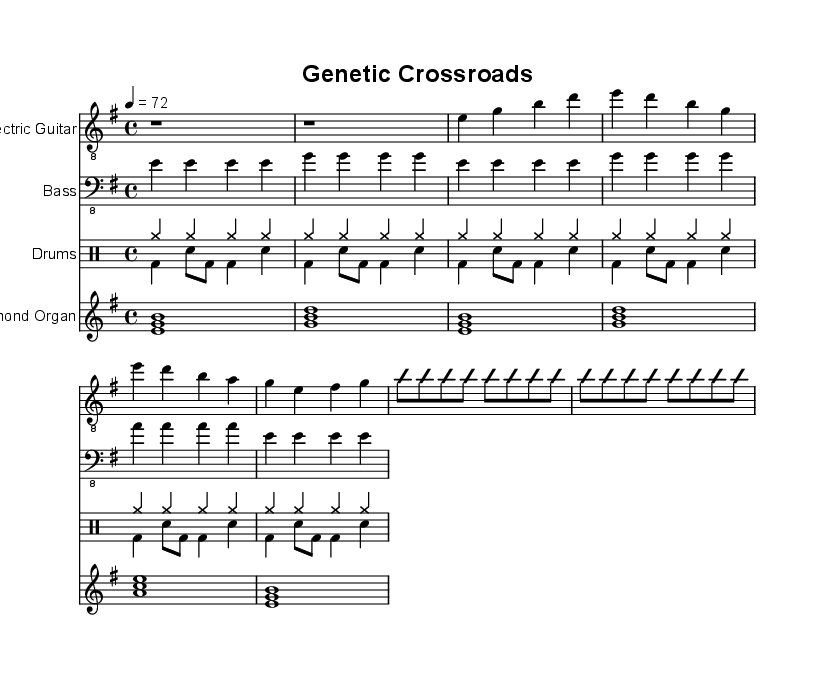What is the key signature of this music? The key signature is E minor, indicating one sharp (F#). This can be identified by the notation at the beginning of the stave which shows the sharp.
Answer: E minor What is the time signature of this music? The time signature is 4/4, which can be observed as there are four beats in each measure and the quarter note gets one beat. This is indicated at the beginning of the sheet music.
Answer: 4/4 What is the tempo marking for this piece? The tempo marking is 72, which specifies that the piece should be played at a speed of 72 beats per minute. This is indicated by the number placed above the staff, after the tempo indication.
Answer: 72 How many measures are there in the verse? There are four measures in the verse, as seen in the section labeled as "Verse 1" consisting of four distinct grouped measures.
Answer: 4 What instrument plays the solo section? The instrument that plays the solo section is the electric guitar, indicated by the label "Electric Guitar" above its staff. It is also the only staff indicated that features improvisation.
Answer: Electric Guitar What chord structure is primarily used in the chorus? The chorus primarily uses the chords E, D, B, and A, which can be seen in the corresponding notes written in the measure during the "Chorus" section of the staff.
Answer: E, D, B, A How many instruments are featured in this sheet music? There are four instruments featured: Electric Guitar, Bass, Drums, and Hammond Organ. Each is listed at the beginning of their respective staves.
Answer: 4 